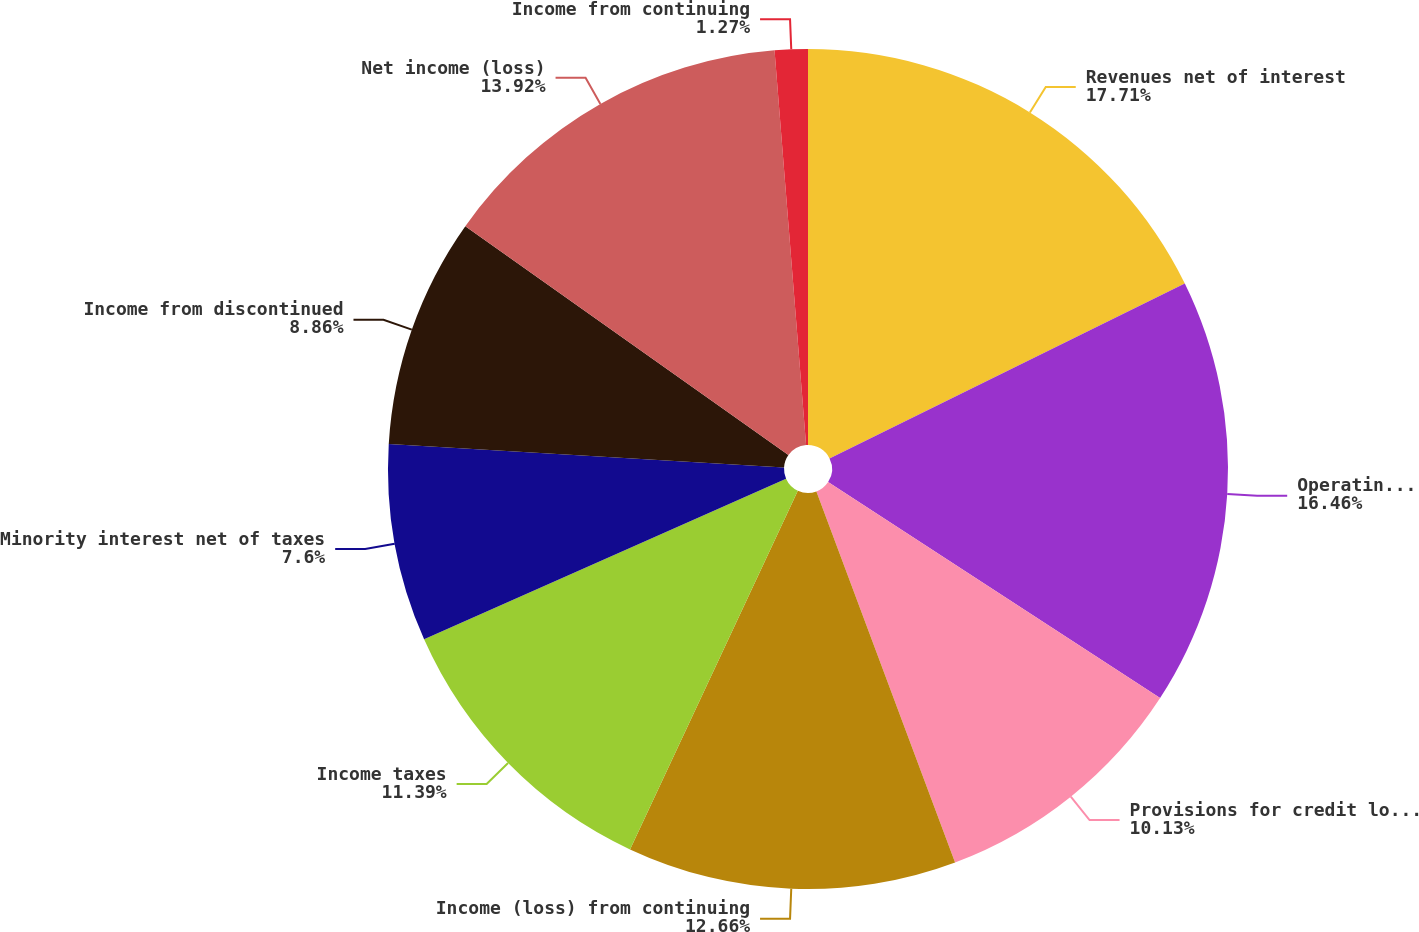Convert chart. <chart><loc_0><loc_0><loc_500><loc_500><pie_chart><fcel>Revenues net of interest<fcel>Operating expenses<fcel>Provisions for credit losses<fcel>Income (loss) from continuing<fcel>Income taxes<fcel>Minority interest net of taxes<fcel>Income from discontinued<fcel>Net income (loss)<fcel>Income from continuing<nl><fcel>17.72%<fcel>16.46%<fcel>10.13%<fcel>12.66%<fcel>11.39%<fcel>7.6%<fcel>8.86%<fcel>13.92%<fcel>1.27%<nl></chart> 